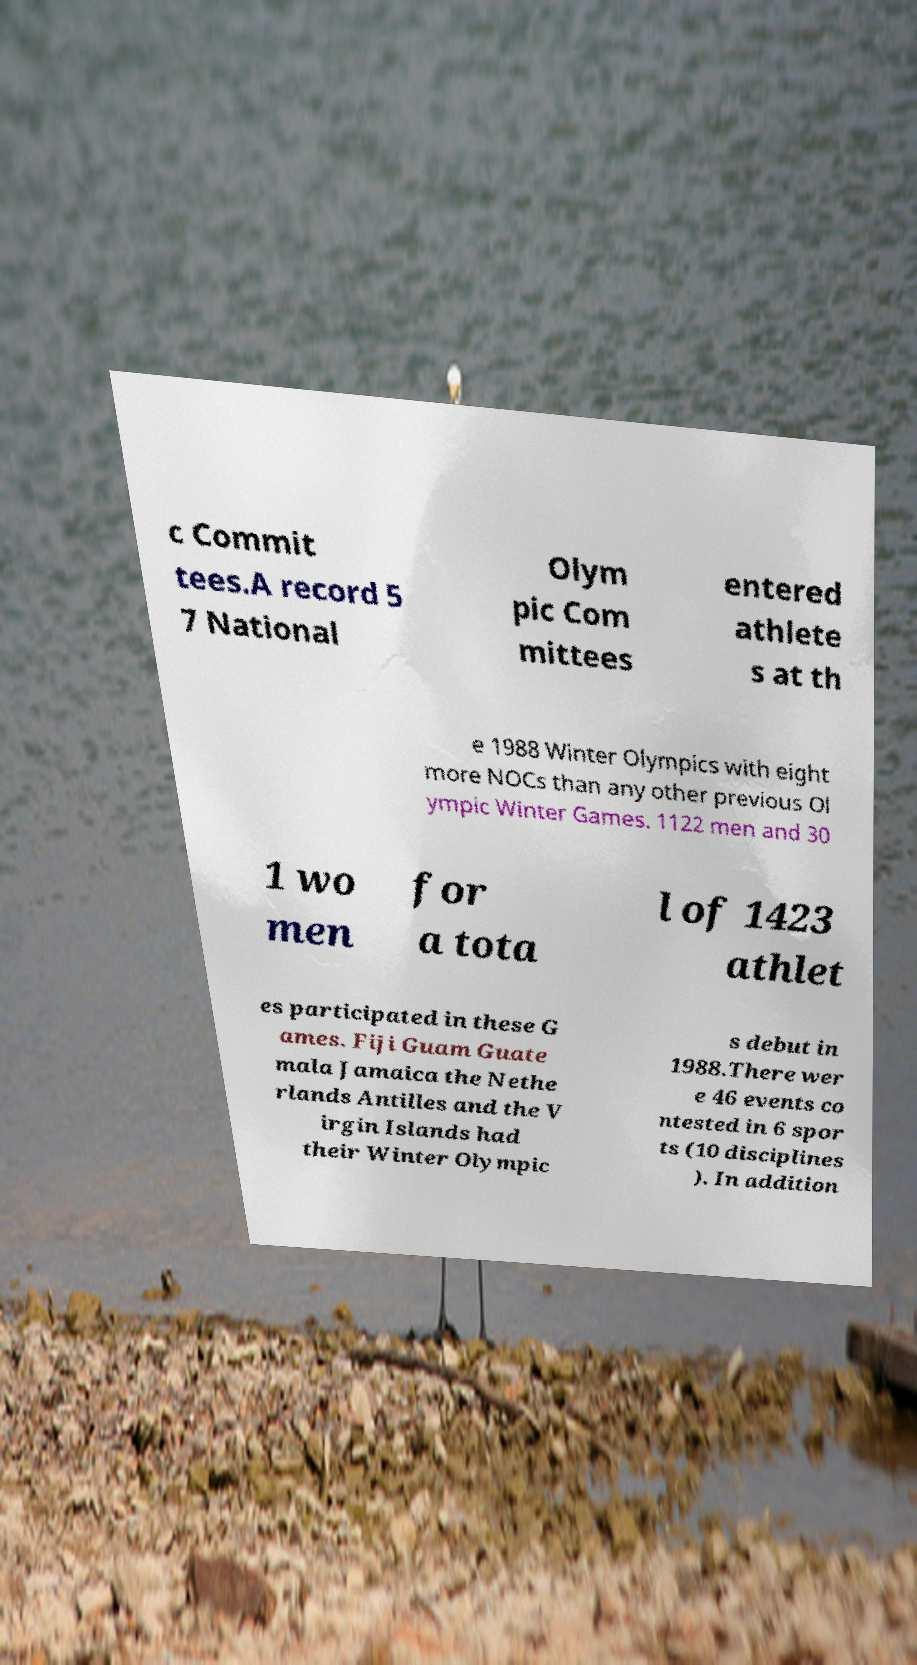Please identify and transcribe the text found in this image. c Commit tees.A record 5 7 National Olym pic Com mittees entered athlete s at th e 1988 Winter Olympics with eight more NOCs than any other previous Ol ympic Winter Games. 1122 men and 30 1 wo men for a tota l of 1423 athlet es participated in these G ames. Fiji Guam Guate mala Jamaica the Nethe rlands Antilles and the V irgin Islands had their Winter Olympic s debut in 1988.There wer e 46 events co ntested in 6 spor ts (10 disciplines ). In addition 